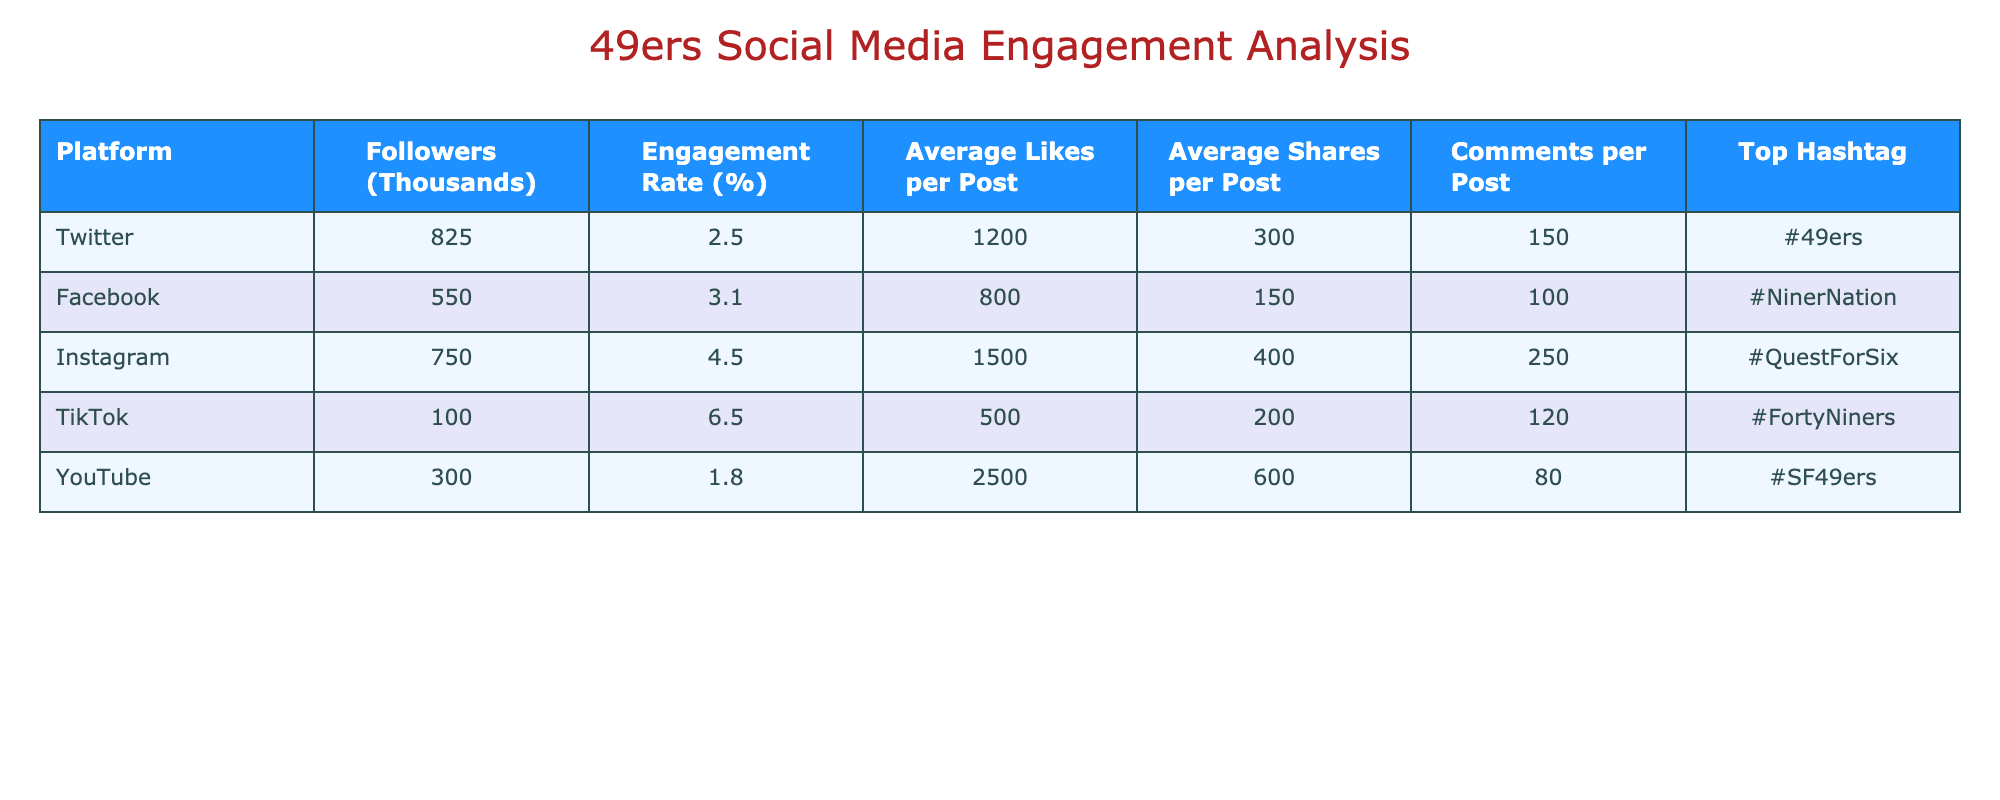What is the engagement rate on TikTok? The engagement rate for TikTok is listed in the table under the "Engagement Rate (%)" column. It shows a value of 6.5%.
Answer: 6.5% Which platform has the highest average likes per post? The average likes per post for each platform are listed in the corresponding column. Instagram has the highest average likes, with a value of 1500.
Answer: Instagram What is the total number of followers (in thousands) across all platforms? To find the total followers, we sum the followers for each platform: 825 (Twitter) + 550 (Facebook) + 750 (Instagram) + 100 (TikTok) + 300 (YouTube) = 2525.
Answer: 2525 Does YouTube have a higher engagement rate than Twitter? By comparing the engagement rates for both platforms: YouTube has an engagement rate of 1.8% and Twitter has 2.5%. Since 1.8% is less than 2.5%, the answer is no.
Answer: No What is the difference in followers between Instagram and Facebook? The followers for Instagram is 750 thousand and for Facebook is 550 thousand. The difference is calculated as 750 - 550 = 200.
Answer: 200 Which platform has the highest average shares per post and what is that number? The average shares per post for each platform are compared: TikTok has 200 shares, Instagram has 400 shares, Facebook has 150 shares, Twitter has 300 shares, and YouTube has 600 shares. The highest number is 600 from YouTube.
Answer: YouTube, 600 Is the average number of comments per post on TikTok higher than on Facebook? The average comments per post are compared: TikTok has 120 comments while Facebook has 100 comments. Since 120 is greater than 100, the answer is yes.
Answer: Yes What is the average engagement rate of all platforms combined? The average engagement rate is computed by adding the engagement rates of each platform and dividing by the total number of platforms: (2.5 + 3.1 + 4.5 + 6.5 + 1.8) / 5 = 3.54.
Answer: 3.54 Which platform uses the hashtag #NinerNation? By checking the "Top Hashtag" column, we find that the platform with the hashtag #NinerNation is Facebook.
Answer: Facebook 